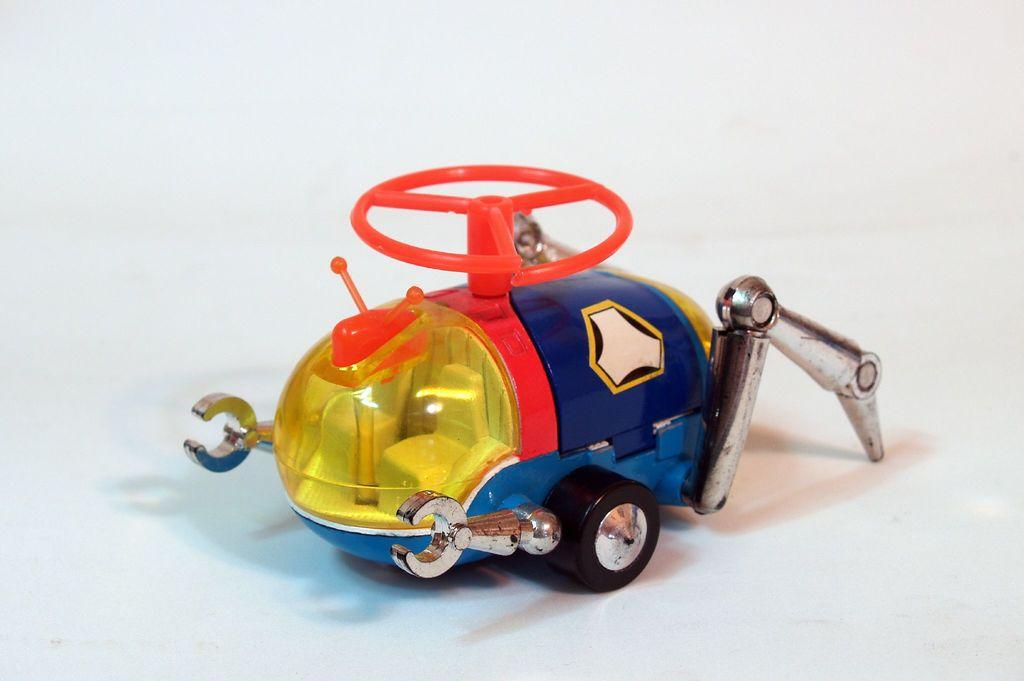What is the main subject in the middle of the image? There is a toy in the middle of the image. What type of verse can be seen written on the toy in the image? There is no verse visible on the toy in the image. Is there a knife present in the image? No, there is no knife present in the image. 